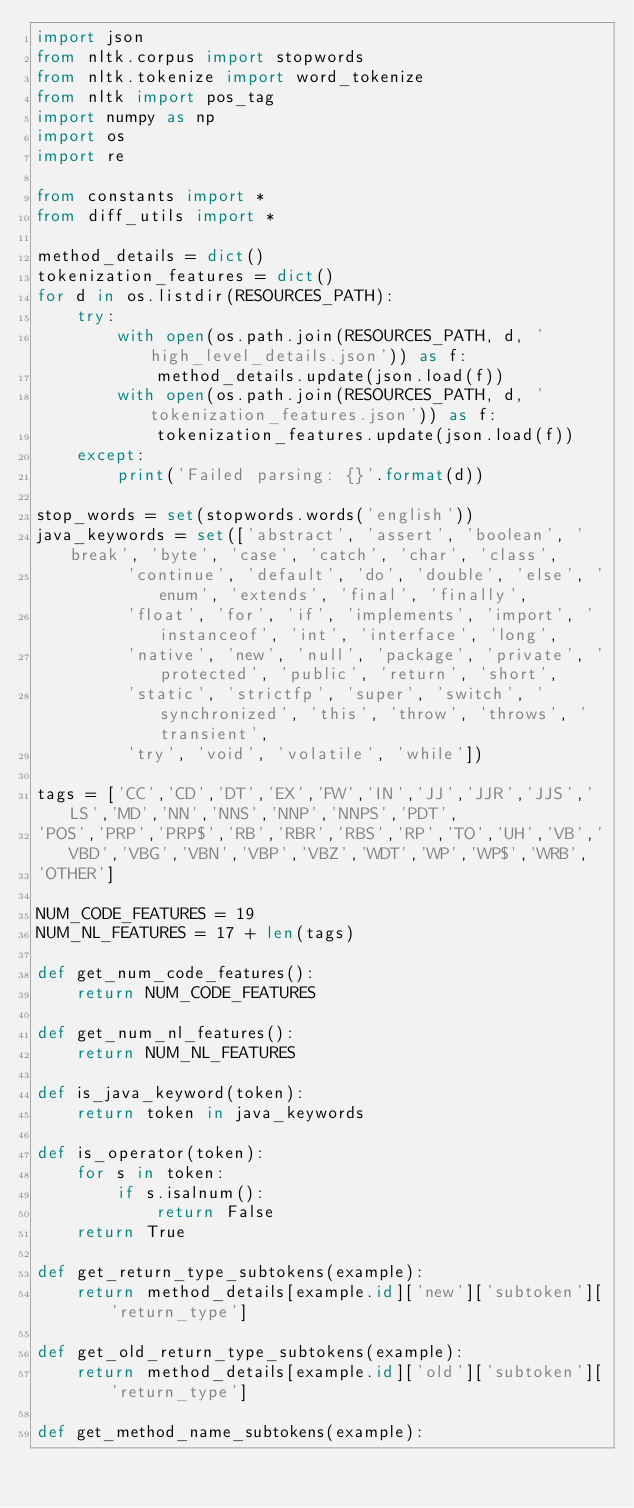<code> <loc_0><loc_0><loc_500><loc_500><_Python_>import json
from nltk.corpus import stopwords
from nltk.tokenize import word_tokenize
from nltk import pos_tag
import numpy as np
import os
import re

from constants import *
from diff_utils import *

method_details = dict()
tokenization_features = dict()
for d in os.listdir(RESOURCES_PATH):
    try:
        with open(os.path.join(RESOURCES_PATH, d, 'high_level_details.json')) as f:
            method_details.update(json.load(f))
        with open(os.path.join(RESOURCES_PATH, d, 'tokenization_features.json')) as f:
            tokenization_features.update(json.load(f))
    except:
        print('Failed parsing: {}'.format(d))

stop_words = set(stopwords.words('english'))
java_keywords = set(['abstract', 'assert', 'boolean', 'break', 'byte', 'case', 'catch', 'char', 'class',
         'continue', 'default', 'do', 'double', 'else', 'enum', 'extends', 'final', 'finally',
         'float', 'for', 'if', 'implements', 'import', 'instanceof', 'int', 'interface', 'long',
         'native', 'new', 'null', 'package', 'private', 'protected', 'public', 'return', 'short',
         'static', 'strictfp', 'super', 'switch', 'synchronized', 'this', 'throw', 'throws', 'transient',
         'try', 'void', 'volatile', 'while'])

tags = ['CC','CD','DT','EX','FW','IN','JJ','JJR','JJS','LS','MD','NN','NNS','NNP','NNPS','PDT',
'POS','PRP','PRP$','RB','RBR','RBS','RP','TO','UH','VB','VBD','VBG','VBN','VBP','VBZ','WDT','WP','WP$','WRB',
'OTHER']

NUM_CODE_FEATURES = 19
NUM_NL_FEATURES = 17 + len(tags)

def get_num_code_features():
    return NUM_CODE_FEATURES

def get_num_nl_features():
    return NUM_NL_FEATURES

def is_java_keyword(token):
    return token in java_keywords

def is_operator(token):
    for s in token:
        if s.isalnum():
            return False
    return True

def get_return_type_subtokens(example):
    return method_details[example.id]['new']['subtoken']['return_type']

def get_old_return_type_subtokens(example):
    return method_details[example.id]['old']['subtoken']['return_type']

def get_method_name_subtokens(example):</code> 